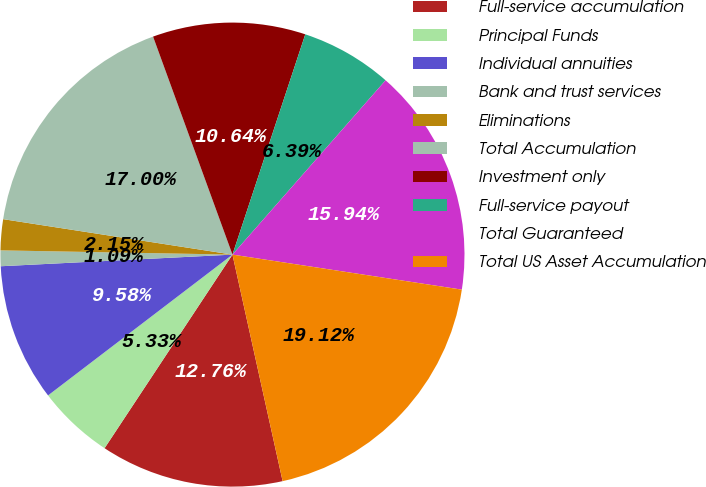<chart> <loc_0><loc_0><loc_500><loc_500><pie_chart><fcel>Full-service accumulation<fcel>Principal Funds<fcel>Individual annuities<fcel>Bank and trust services<fcel>Eliminations<fcel>Total Accumulation<fcel>Investment only<fcel>Full-service payout<fcel>Total Guaranteed<fcel>Total US Asset Accumulation<nl><fcel>12.76%<fcel>5.33%<fcel>9.58%<fcel>1.09%<fcel>2.15%<fcel>17.0%<fcel>10.64%<fcel>6.39%<fcel>15.94%<fcel>19.12%<nl></chart> 